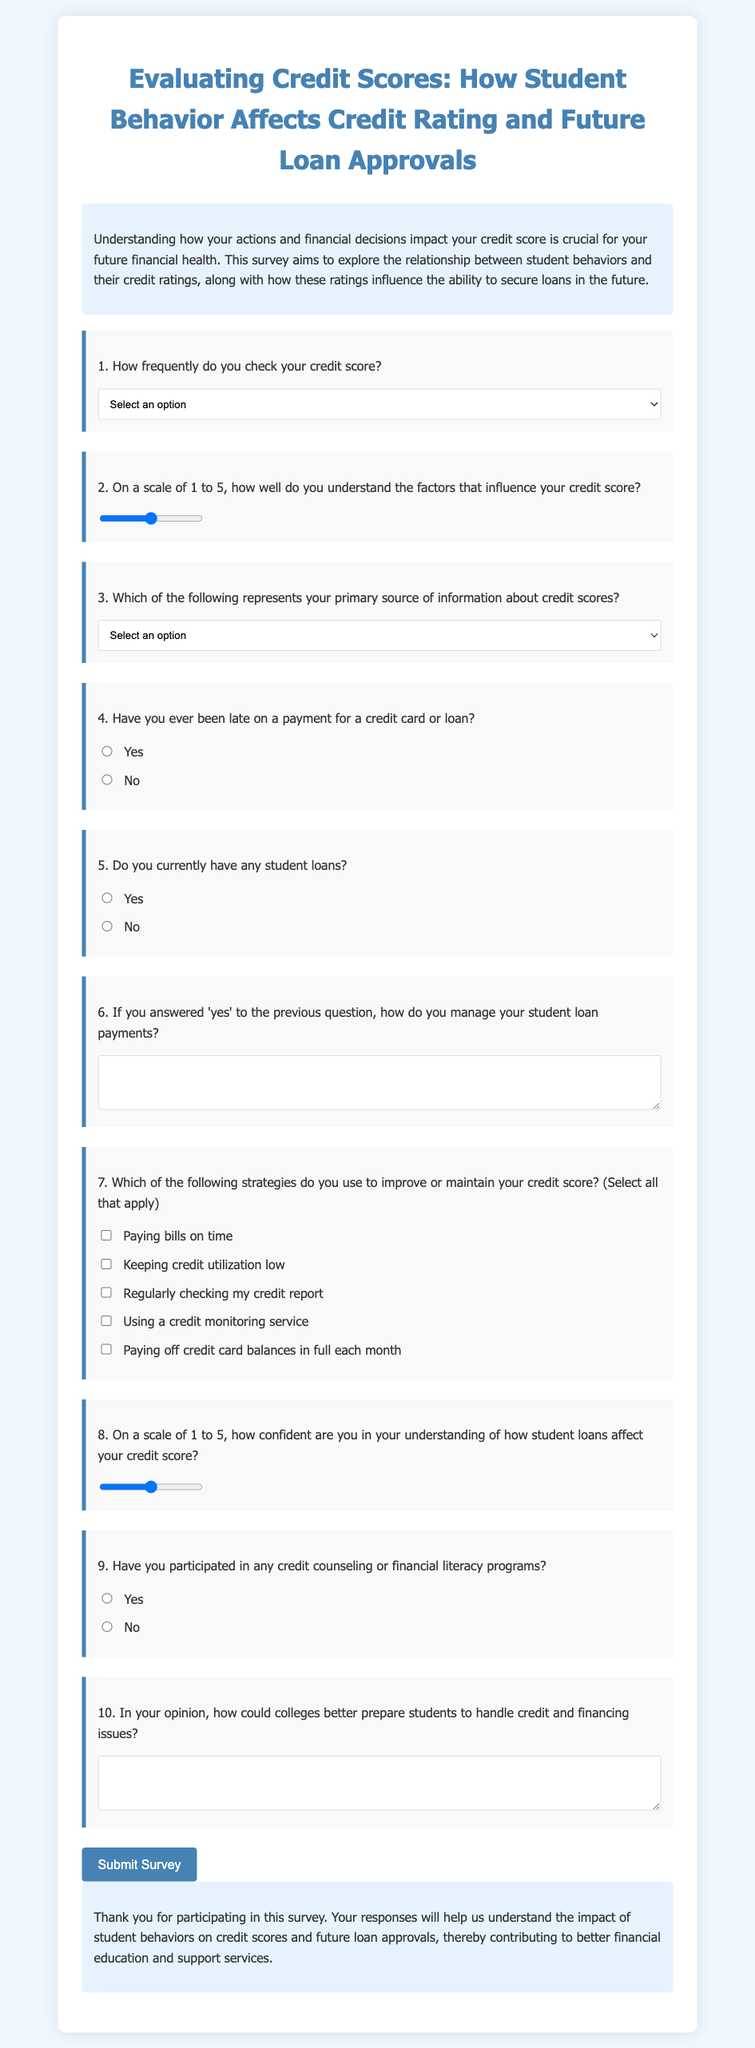1. What is the title of the survey? The title is displayed prominently at the top of the survey form, indicating the focus and purpose of the study.
Answer: Evaluating Credit Scores: How Student Behavior Affects Credit Rating and Future Loan Approvals 2. How often do students check their credit score according to the survey? This information is captured in the first question of the survey, offering a range of options for students to select from.
Answer: Select an option 3. What scale is used to assess understanding of credit score factors? The second question uses a numeric scale to gauge respondents' comprehension level about credit scores.
Answer: 1 to 5 4. Who are financial advisors in the context of this survey? Financial advisors are mentioned as one of the sources of information regarding credit scores in the options of the third question.
Answer: Primary source of information 5. What type of question is asked about late payments? The question assesses a specific behavior of respondents regarding credit management, targeted towards their past actions.
Answer: Yes or No 6. What action is asked if a student currently has student loans? This question seeks qualitative information on how students manage their financial responsibilities related to loans.
Answer: Manage student loan payments 7. Which strategies are suggested to improve credit score? The survey includes a question about methods that students might use to maintain or enhance their credit ratings.
Answer: Select all that apply 8. What understanding level regarding student loans is assessed in the survey? This question focuses on a metric of confidence that respondents have in relation to student loans affecting their credit score.
Answer: 1 to 5 9. What is the conclusion's main message? The conclusion summarizes the purpose and significance of the survey, emphasizing the potential benefits of the gathered data.
Answer: Thank you for participating in this survey 10. How does the survey suggest colleges can help students with credit issues? The last question invites respondents to share their thoughts on improvements in educational approaches related to financing.
Answer: Handle credit and financing issues 